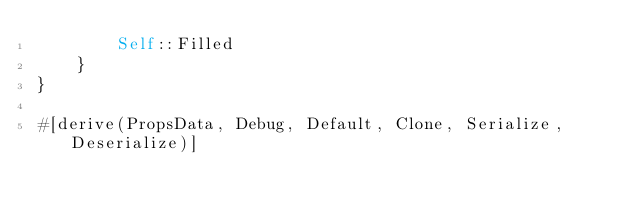Convert code to text. <code><loc_0><loc_0><loc_500><loc_500><_Rust_>        Self::Filled
    }
}

#[derive(PropsData, Debug, Default, Clone, Serialize, Deserialize)]</code> 